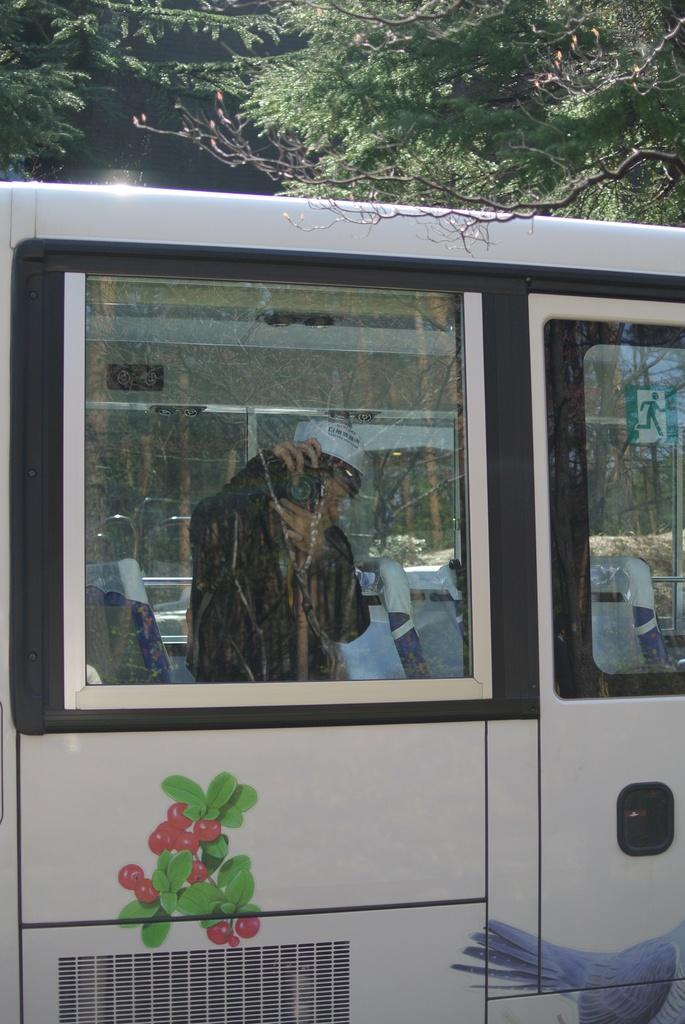What is the main subject in the foreground of the image? There is a vehicle in the foreground of the image. Who is inside the vehicle? A person is inside the vehicle. What is the person holding? The person is holding a camera. What type of barrier is present between the person and the outside environment? There is a glass window in the vehicle. What can be seen in the background of the image? Trees are visible on the top of the image. What is the profit margin of the vehicle in the image? There is no information about the profit margin of the vehicle in the image. Can you tell me the story behind the person holding the camera in the image? There is no story provided in the image; it only shows a person holding a camera inside a vehicle. 